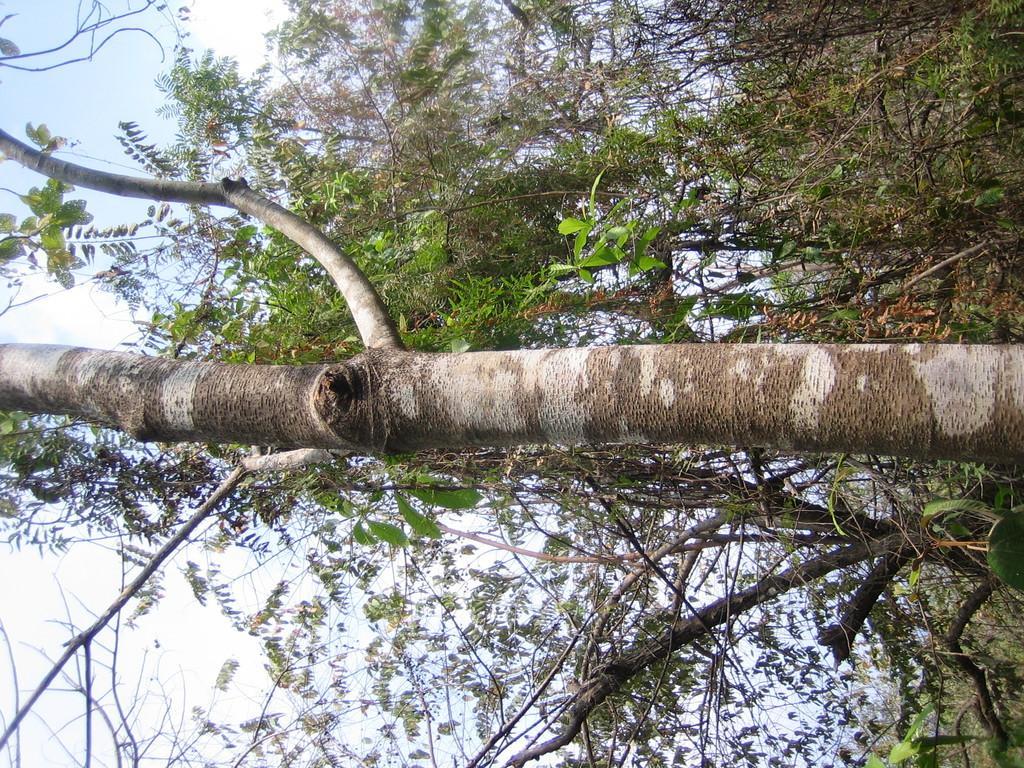Describe this image in one or two sentences. Here we can see trees. In the background there is sky. 